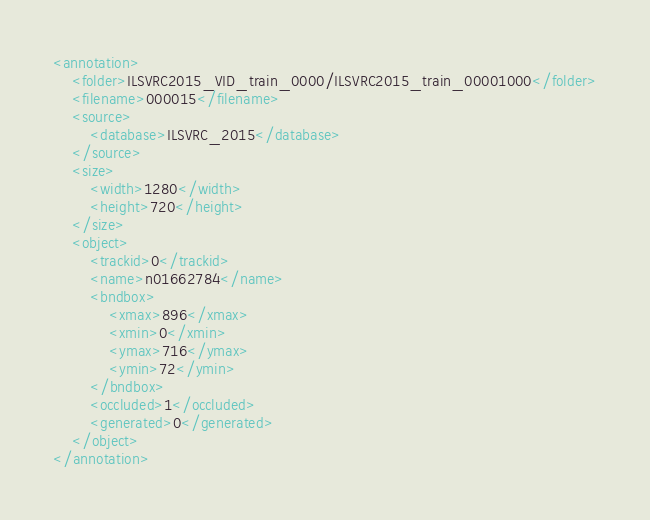<code> <loc_0><loc_0><loc_500><loc_500><_XML_><annotation>
	<folder>ILSVRC2015_VID_train_0000/ILSVRC2015_train_00001000</folder>
	<filename>000015</filename>
	<source>
		<database>ILSVRC_2015</database>
	</source>
	<size>
		<width>1280</width>
		<height>720</height>
	</size>
	<object>
		<trackid>0</trackid>
		<name>n01662784</name>
		<bndbox>
			<xmax>896</xmax>
			<xmin>0</xmin>
			<ymax>716</ymax>
			<ymin>72</ymin>
		</bndbox>
		<occluded>1</occluded>
		<generated>0</generated>
	</object>
</annotation>
</code> 